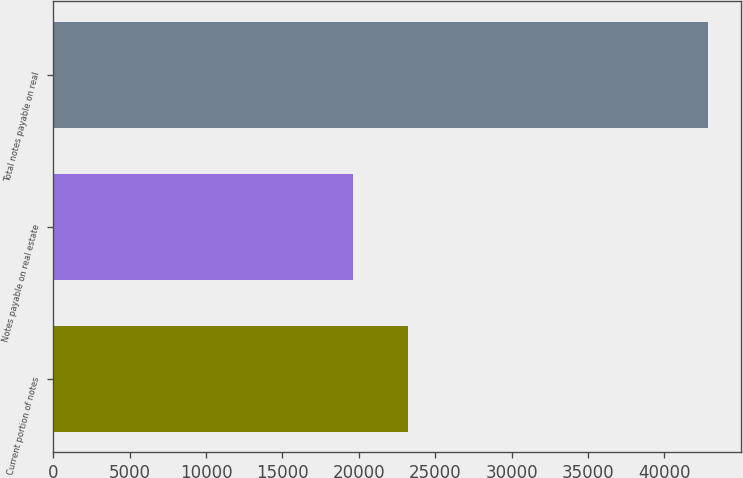Convert chart. <chart><loc_0><loc_0><loc_500><loc_500><bar_chart><fcel>Current portion of notes<fcel>Notes payable on real estate<fcel>Total notes payable on real<nl><fcel>23229<fcel>19614<fcel>42843<nl></chart> 